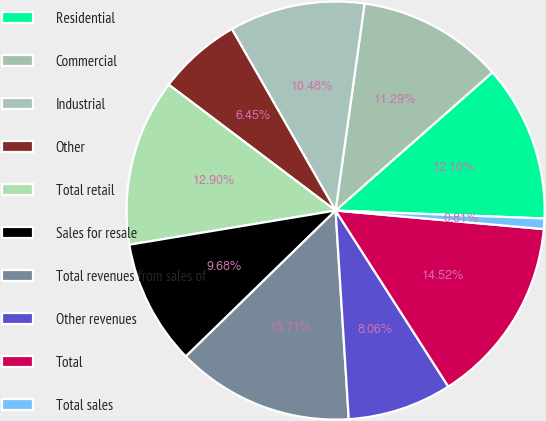Convert chart to OTSL. <chart><loc_0><loc_0><loc_500><loc_500><pie_chart><fcel>Residential<fcel>Commercial<fcel>Industrial<fcel>Other<fcel>Total retail<fcel>Sales for resale<fcel>Total revenues from sales of<fcel>Other revenues<fcel>Total<fcel>Total sales<nl><fcel>12.1%<fcel>11.29%<fcel>10.48%<fcel>6.45%<fcel>12.9%<fcel>9.68%<fcel>13.71%<fcel>8.06%<fcel>14.52%<fcel>0.81%<nl></chart> 